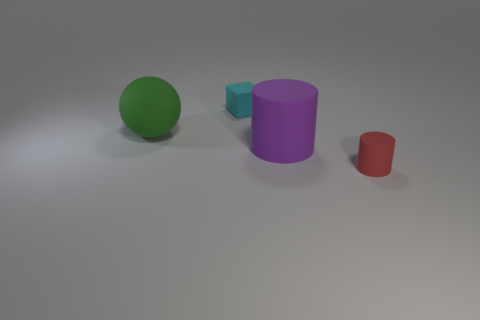How many things are right of the purple object that is in front of the large object that is left of the tiny cyan object?
Offer a very short reply. 1. Are there any large green balls behind the tiny matte cylinder?
Your response must be concise. Yes. How many big green objects have the same material as the ball?
Provide a short and direct response. 0. How many things are large cyan metallic cubes or red cylinders?
Your answer should be very brief. 1. Are any cyan metallic cylinders visible?
Ensure brevity in your answer.  No. There is a large thing that is in front of the big matte sphere left of the tiny rubber object that is in front of the cyan matte object; what is its material?
Your answer should be very brief. Rubber. Are there fewer big green spheres to the right of the tiny cyan thing than matte objects?
Offer a terse response. Yes. What is the size of the rubber object that is both left of the small cylinder and in front of the big matte sphere?
Offer a terse response. Large. There is a red rubber object that is the same shape as the purple thing; what is its size?
Your answer should be compact. Small. How many things are either tiny red things or matte things that are left of the big purple rubber object?
Give a very brief answer. 3. 